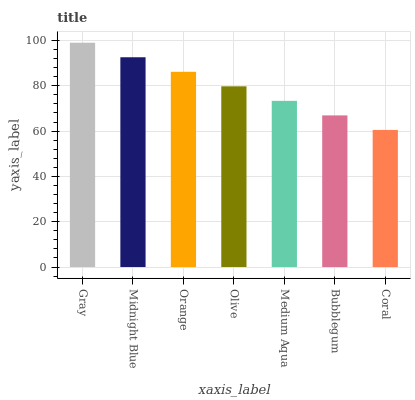Is Midnight Blue the minimum?
Answer yes or no. No. Is Midnight Blue the maximum?
Answer yes or no. No. Is Gray greater than Midnight Blue?
Answer yes or no. Yes. Is Midnight Blue less than Gray?
Answer yes or no. Yes. Is Midnight Blue greater than Gray?
Answer yes or no. No. Is Gray less than Midnight Blue?
Answer yes or no. No. Is Olive the high median?
Answer yes or no. Yes. Is Olive the low median?
Answer yes or no. Yes. Is Gray the high median?
Answer yes or no. No. Is Orange the low median?
Answer yes or no. No. 